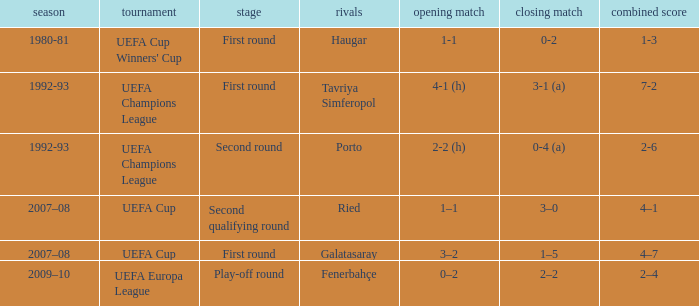 what's the competition where aggregate is 4–7 UEFA Cup. 